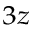Convert formula to latex. <formula><loc_0><loc_0><loc_500><loc_500>_ { 3 z }</formula> 